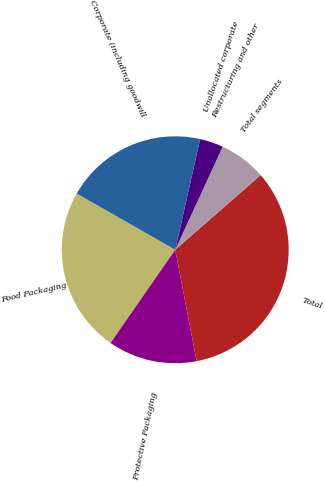<chart> <loc_0><loc_0><loc_500><loc_500><pie_chart><fcel>Food Packaging<fcel>Protective Packaging<fcel>Total<fcel>Total segments<fcel>Restructuring and other<fcel>Unallocated corporate<fcel>Corporate (including goodwill<nl><fcel>23.6%<fcel>12.68%<fcel>33.4%<fcel>6.69%<fcel>0.01%<fcel>3.35%<fcel>20.26%<nl></chart> 